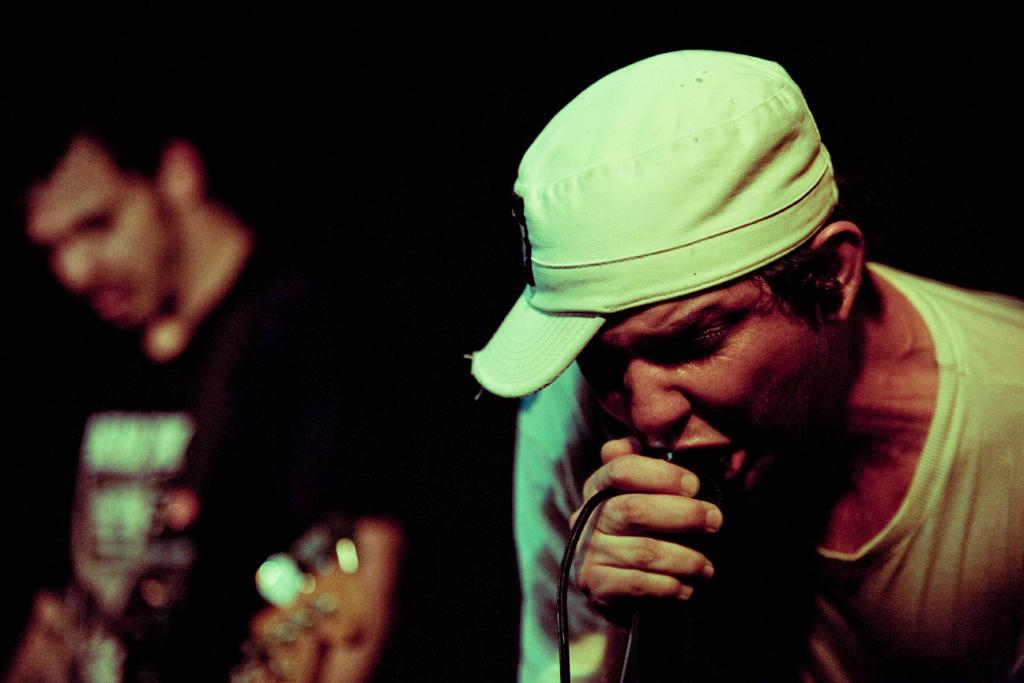What is the man in the image doing? The man is singing. What is the man holding in his hand? The man is holding a mic. Can you describe the man's headwear? The man is wearing a cap on his head. Is there anyone else in the image? Yes, there is another man in the background of the image. What is the man in the background holding? The man in the background is holding a guitar. How is the guitar in the background depicted? The guitar in the background is slightly blurred. What type of chalk is the man using to draw on the wall in the image? There is no chalk or drawing on the wall present in the image. What sound can be heard coming from the man in the image? The image is static, so no sound can be heard. 